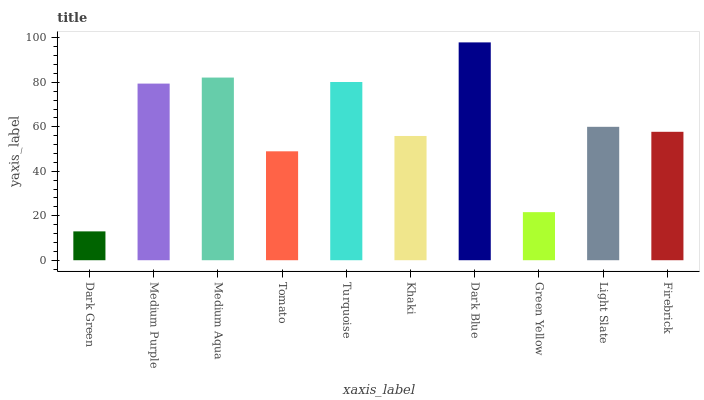Is Medium Purple the minimum?
Answer yes or no. No. Is Medium Purple the maximum?
Answer yes or no. No. Is Medium Purple greater than Dark Green?
Answer yes or no. Yes. Is Dark Green less than Medium Purple?
Answer yes or no. Yes. Is Dark Green greater than Medium Purple?
Answer yes or no. No. Is Medium Purple less than Dark Green?
Answer yes or no. No. Is Light Slate the high median?
Answer yes or no. Yes. Is Firebrick the low median?
Answer yes or no. Yes. Is Dark Blue the high median?
Answer yes or no. No. Is Tomato the low median?
Answer yes or no. No. 